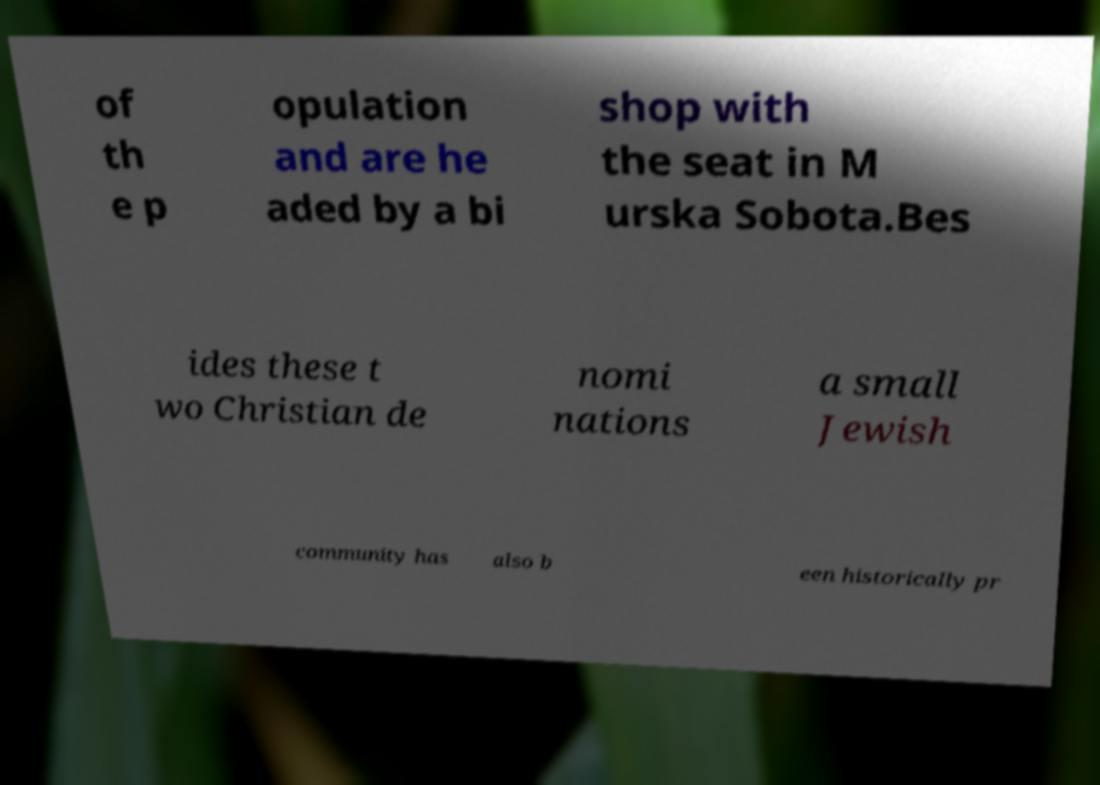What messages or text are displayed in this image? I need them in a readable, typed format. of th e p opulation and are he aded by a bi shop with the seat in M urska Sobota.Bes ides these t wo Christian de nomi nations a small Jewish community has also b een historically pr 